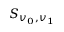Convert formula to latex. <formula><loc_0><loc_0><loc_500><loc_500>S _ { v _ { 0 } , v _ { 1 } }</formula> 